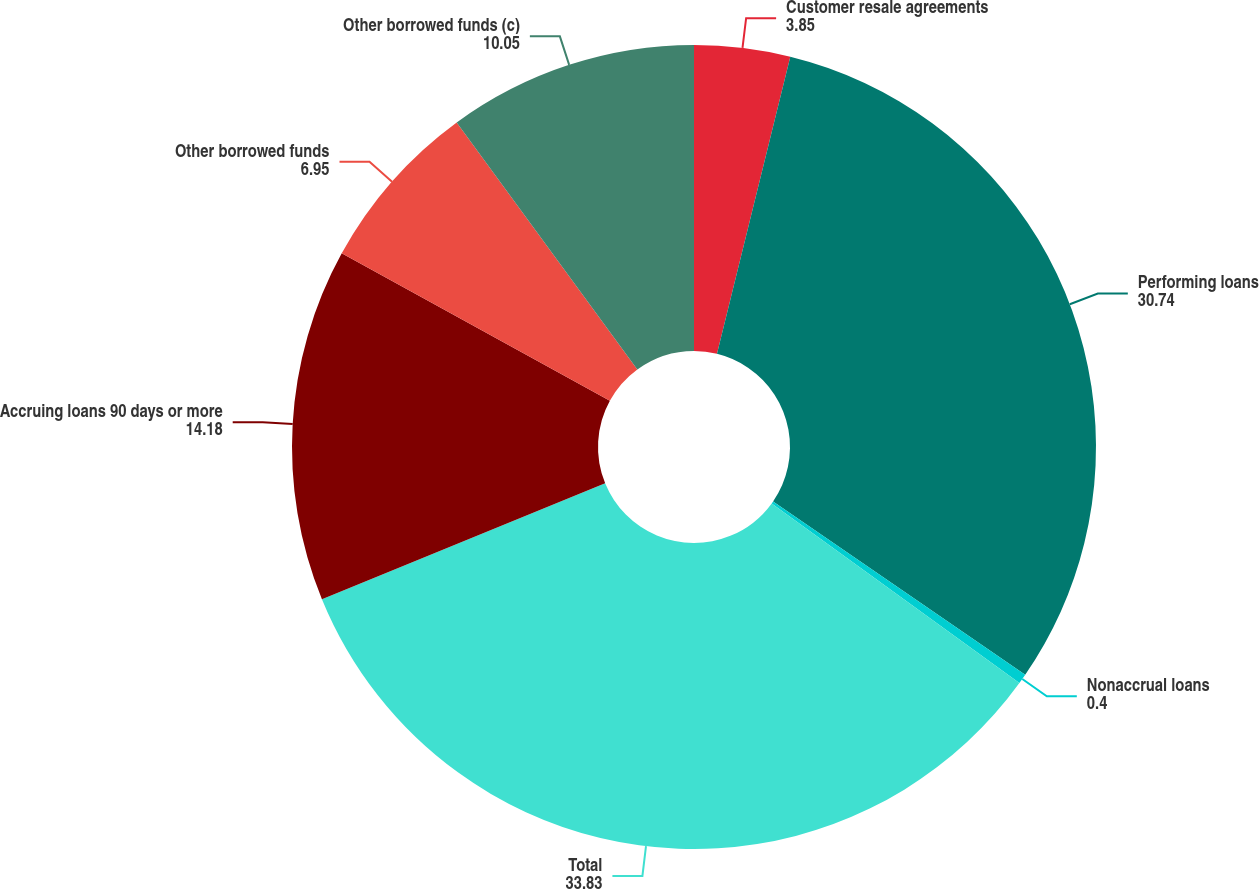Convert chart. <chart><loc_0><loc_0><loc_500><loc_500><pie_chart><fcel>Customer resale agreements<fcel>Performing loans<fcel>Nonaccrual loans<fcel>Total<fcel>Accruing loans 90 days or more<fcel>Other borrowed funds<fcel>Other borrowed funds (c)<nl><fcel>3.85%<fcel>30.74%<fcel>0.4%<fcel>33.83%<fcel>14.18%<fcel>6.95%<fcel>10.05%<nl></chart> 